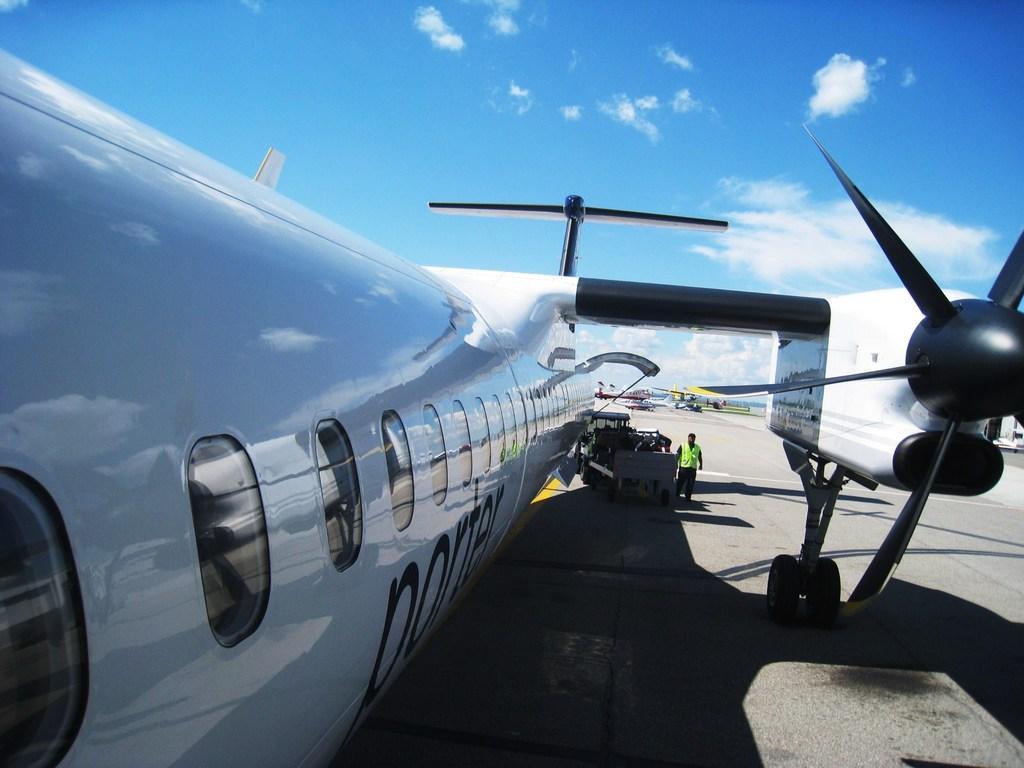Can you describe this image briefly? In this picture we can see an airplane and a person on the path. Behind the airplane there are some other vehicles and the sky. 